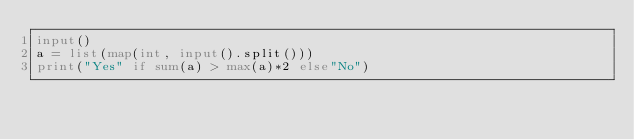<code> <loc_0><loc_0><loc_500><loc_500><_Python_>input()
a = list(map(int, input().split()))
print("Yes" if sum(a) > max(a)*2 else"No")</code> 